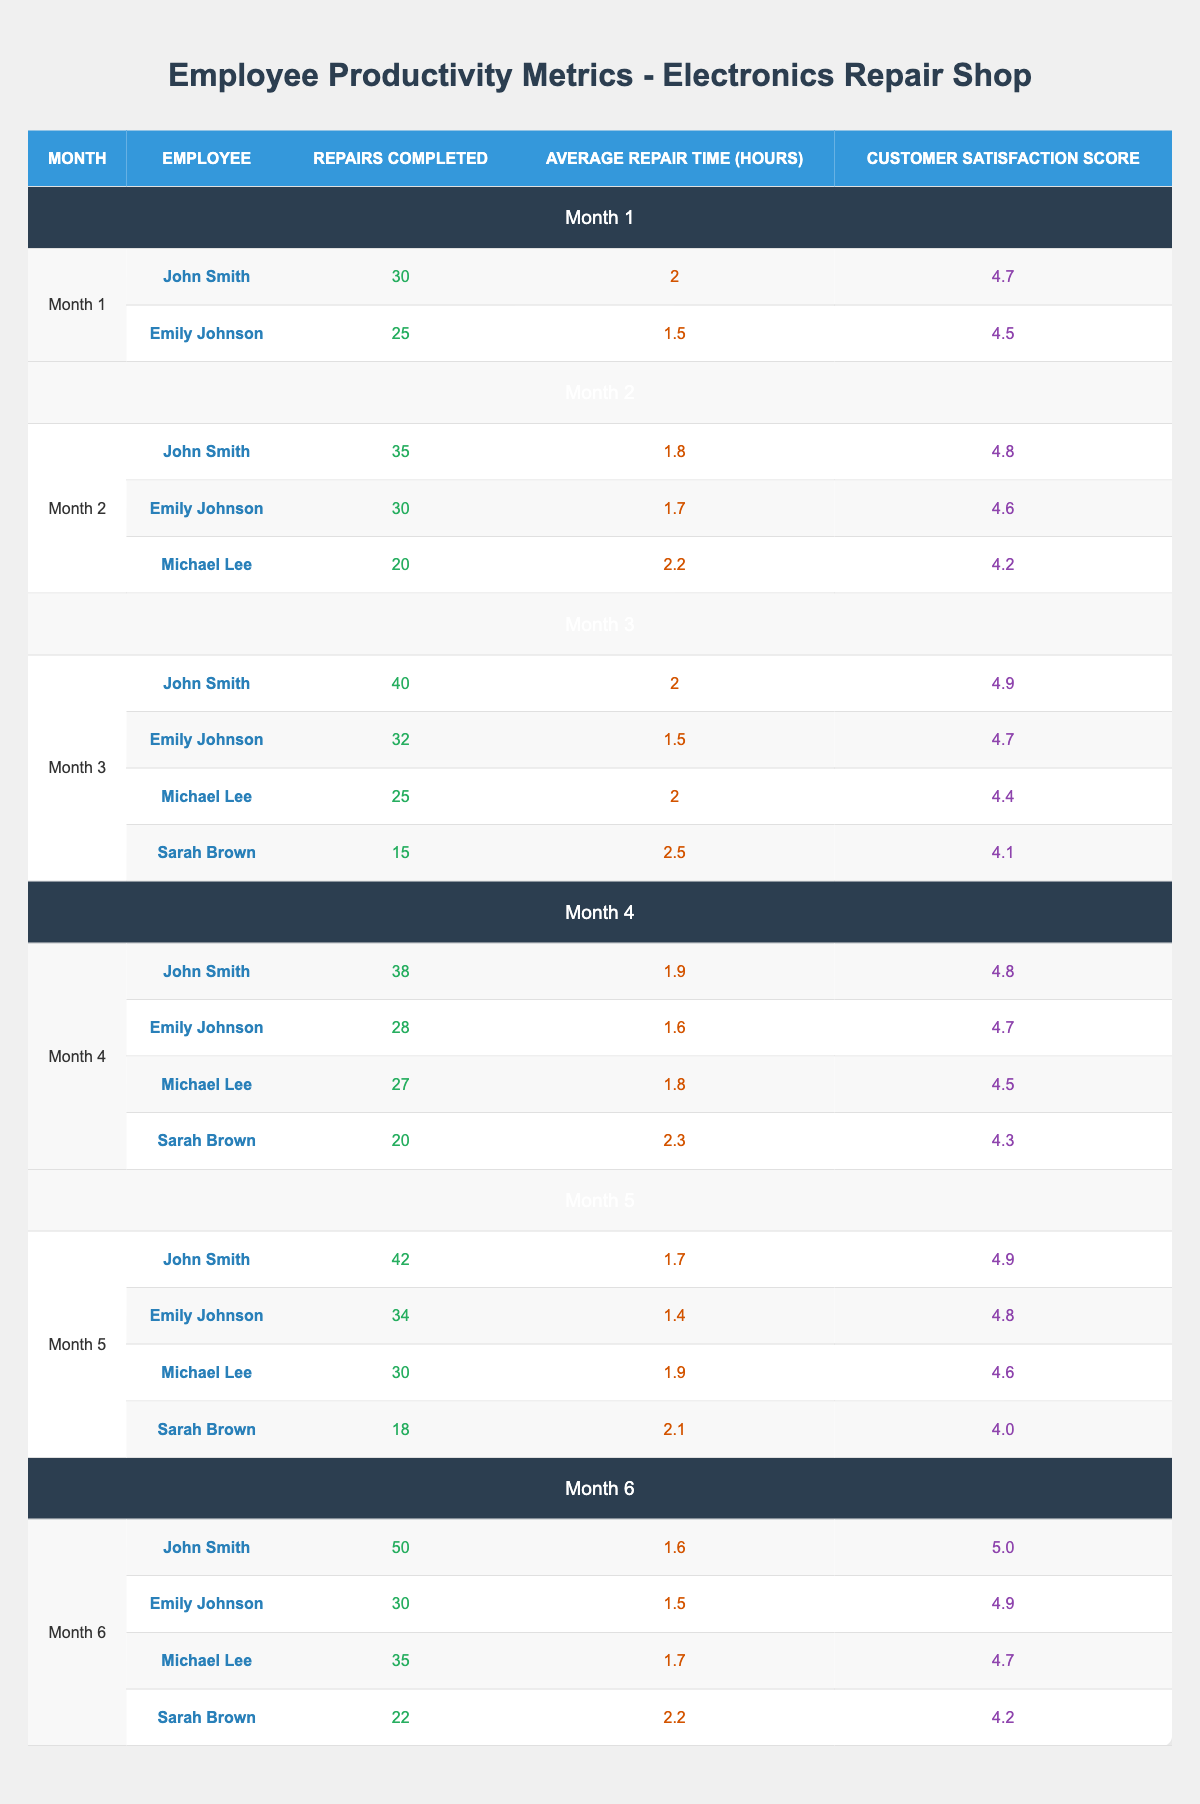What was the Customer Satisfaction Score for John Smith in Month 6? In Month 6, the table shows that John Smith had a Customer Satisfaction Score of 5.0, which is listed under his evaluations for that month.
Answer: 5.0 How many repairs did Emily Johnson complete in Month 5? The table indicates that Emily Johnson completed 34 repairs in Month 5, which is explicitly stated in the corresponding row for that month.
Answer: 34 Which employee had the lowest average repair time in Month 3, and what was that time? By examining the rows for Month 3, we find that Emily Johnson had the lowest average repair time of 1.5 hours among the employees listed, as shown in her row.
Answer: Emily Johnson; 1.5 hours What was the total number of repairs completed by Michael Lee over the six months? To find this, we need to sum Michael Lee’s repairs across all six months: 20 (Month 2) + 25 (Month 3) + 27 (Month 4) + 30 (Month 5) + 35 (Month 6) = 137 repairs total.
Answer: 137 Did Sarah Brown have a Customer Satisfaction Score of 4.5 or higher in any of the months? Checking the table, Sarah Brown’s scores were 4.1 (Month 3), 4.3 (Month 4), 4.0 (Month 5), and 4.2 (Month 6). None of these scores is 4.5 or higher, so the answer is no.
Answer: No What was the average number of repairs completed by John Smith over the six months? John Smith completed: 30 (Month 1) + 35 (Month 2) + 40 (Month 3) + 38 (Month 4) + 42 (Month 5) + 50 (Month 6) = 235 repairs. Dividing by 6 months gives an average of 235 / 6 = ~39.17.
Answer: ~39.17 Which month had the highest total repairs completed by all employees combined, and what was that total? We calculate the total repairs for each month: Month 1: 55; Month 2: 85; Month 3: 112; Month 4: 113; Month 5: 124; Month 6: 137. Month 6 had the highest total with 137 repairs.
Answer: Month 6; 137 How much did the average Customer Satisfaction Score for all employees change from Month 1 to Month 6? In Month 1, the average Customer Satisfaction Score was (4.7 + 4.5) / 2 = 4.6. In Month 6, it is (5.0 + 4.9 + 4.7 + 4.2) / 4 = 4.52. The change from Month 1 to Month 6 is 4.52 - 4.6 = -0.08.
Answer: -0.08 